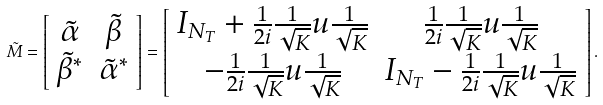<formula> <loc_0><loc_0><loc_500><loc_500>\tilde { M } = \left [ \begin{array} { c c } \tilde { \alpha } & \tilde { \beta } \\ \tilde { \beta } ^ { \ast } & \tilde { \alpha } ^ { \ast } \end{array} \right ] = \left [ \begin{array} { c c } I _ { N _ { T } } + \frac { 1 } { 2 i } \frac { 1 } { \sqrt { K } } u \frac { 1 } { \sqrt { K } } & \frac { 1 } { 2 i } \frac { 1 } { \sqrt { K } } u \frac { 1 } { \sqrt { K } } \\ - \frac { 1 } { 2 i } \frac { 1 } { \sqrt { K } } u \frac { 1 } { \sqrt { K } } & I _ { N _ { T } } - \frac { 1 } { 2 i } \frac { 1 } { \sqrt { K } } u \frac { 1 } { \sqrt { K } } \end{array} \right ] . \\</formula> 